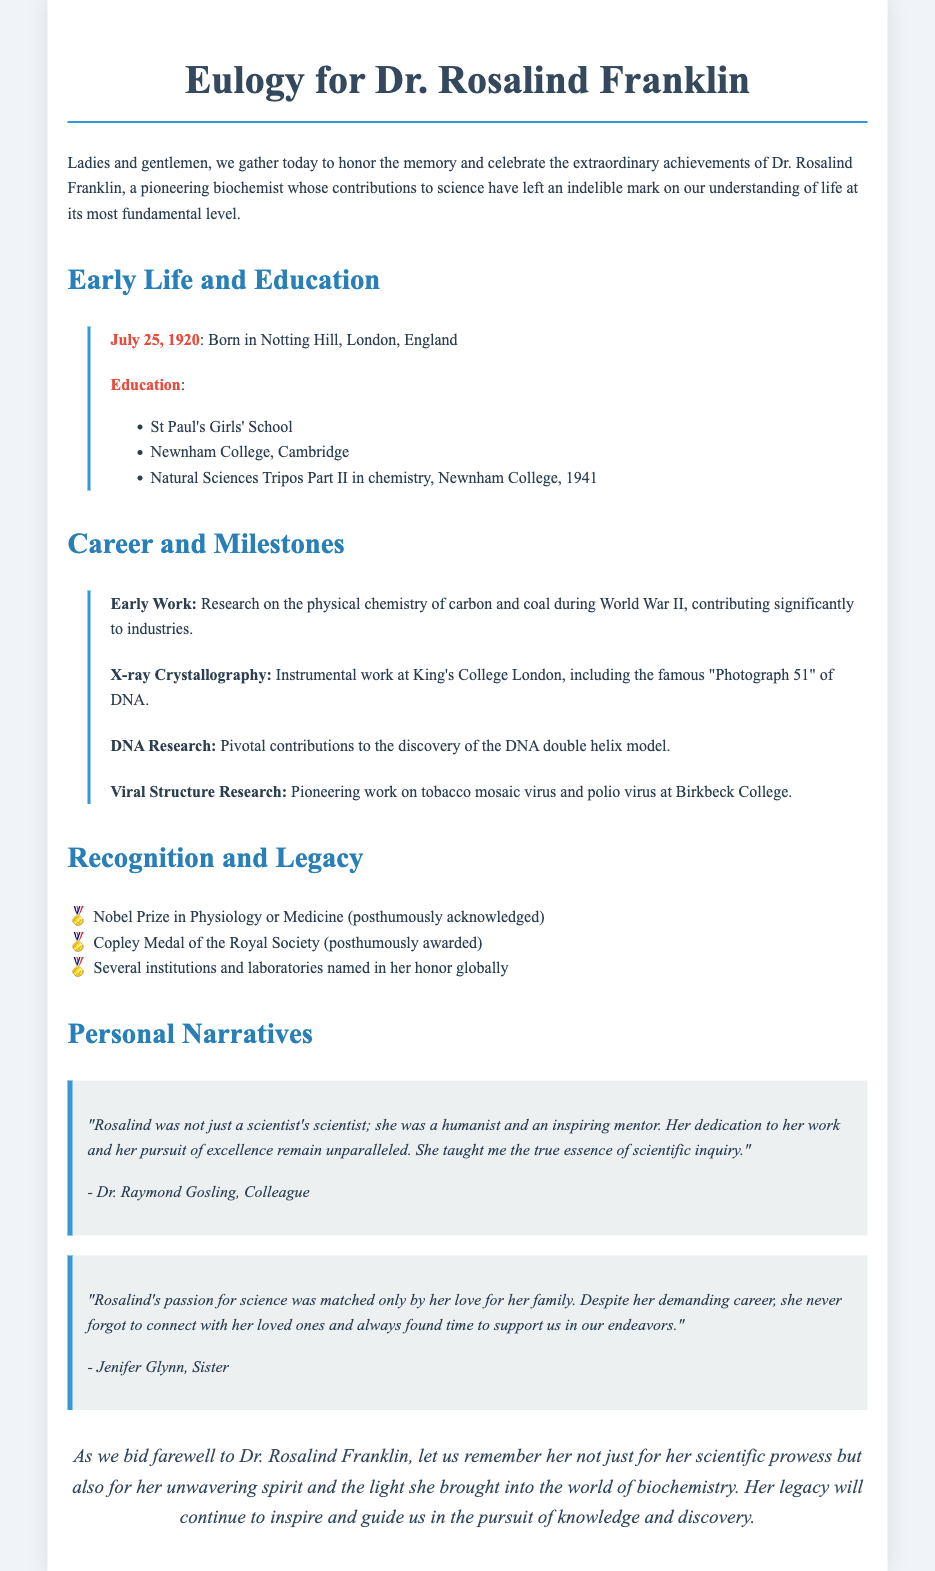What is the full name of the biochemist being honored? The document mentions the full name of the biochemist as Dr. Rosalind Franklin.
Answer: Dr. Rosalind Franklin When was Dr. Rosalind Franklin born? The timeline in the document states her birth date as July 25, 1920.
Answer: July 25, 1920 What significant discovery is Dr. Franklin known for in relation to DNA? The document highlights her pivotal contributions to the discovery of the DNA double helix model.
Answer: DNA double helix model Which prestigious award was mentioned as being awarded posthumously to Dr. Franklin? The document lists the Nobel Prize in Physiology or Medicine as awarded posthumously.
Answer: Nobel Prize in Physiology or Medicine What aspect of Dr. Franklin's character does Dr. Raymond Gosling emphasize in his quote? The quote mentions she was a humanist and an inspiring mentor, emphasizing her character.
Answer: Humanist and inspiring mentor How many educational institutions or laboratories are named in Dr. Franklin's honor, according to the document? The document states that several institutions and laboratories are named in her honor globally, although it does not specify a number.
Answer: Several What type of research did Dr. Franklin conduct during World War II? The document states that she researched the physical chemistry of carbon and coal during World War II.
Answer: Physical chemistry of carbon and coal What was Dr. Franklin's primary field of study? The document identifies her primary field as biochemistry.
Answer: Biochemistry What is indicated as Dr. Franklin's legacy in the closing remarks? The closing remarks suggest her legacy will inspire and guide in the pursuit of knowledge and discovery.
Answer: Inspire and guide in the pursuit of knowledge and discovery 